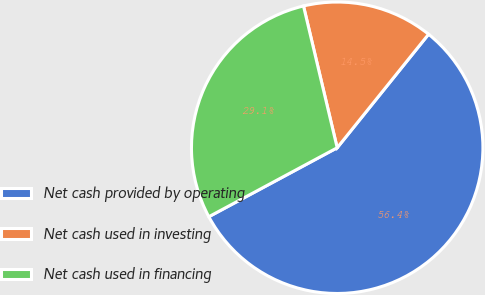<chart> <loc_0><loc_0><loc_500><loc_500><pie_chart><fcel>Net cash provided by operating<fcel>Net cash used in investing<fcel>Net cash used in financing<nl><fcel>56.36%<fcel>14.5%<fcel>29.13%<nl></chart> 